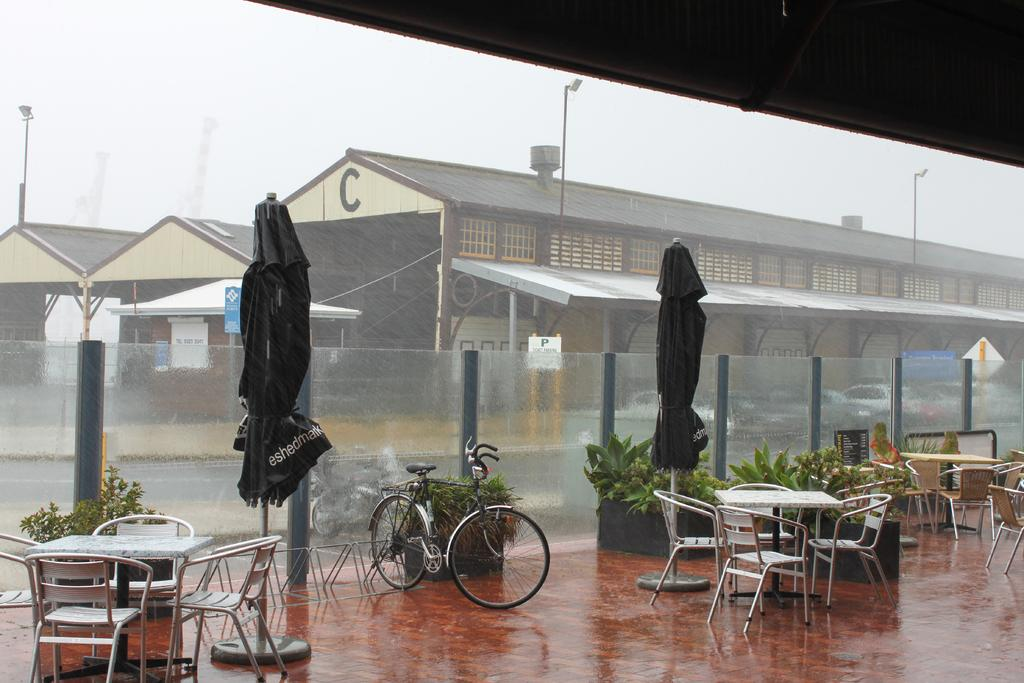What type of structure is visible in the image? There is a building in the image. What objects are present to provide shelter from the rain or sun? There are umbrellas in the image. What mode of transportation can be seen in the image? There is a bicycle in the image. What type of vegetation is present in the image? There are plants in the image. What type of furniture is visible in the image? There are chairs and tables in the image. How many apples are being shown in the image? There are no apples present in the image. What shape is the square in the image? There is no square present in the image. 